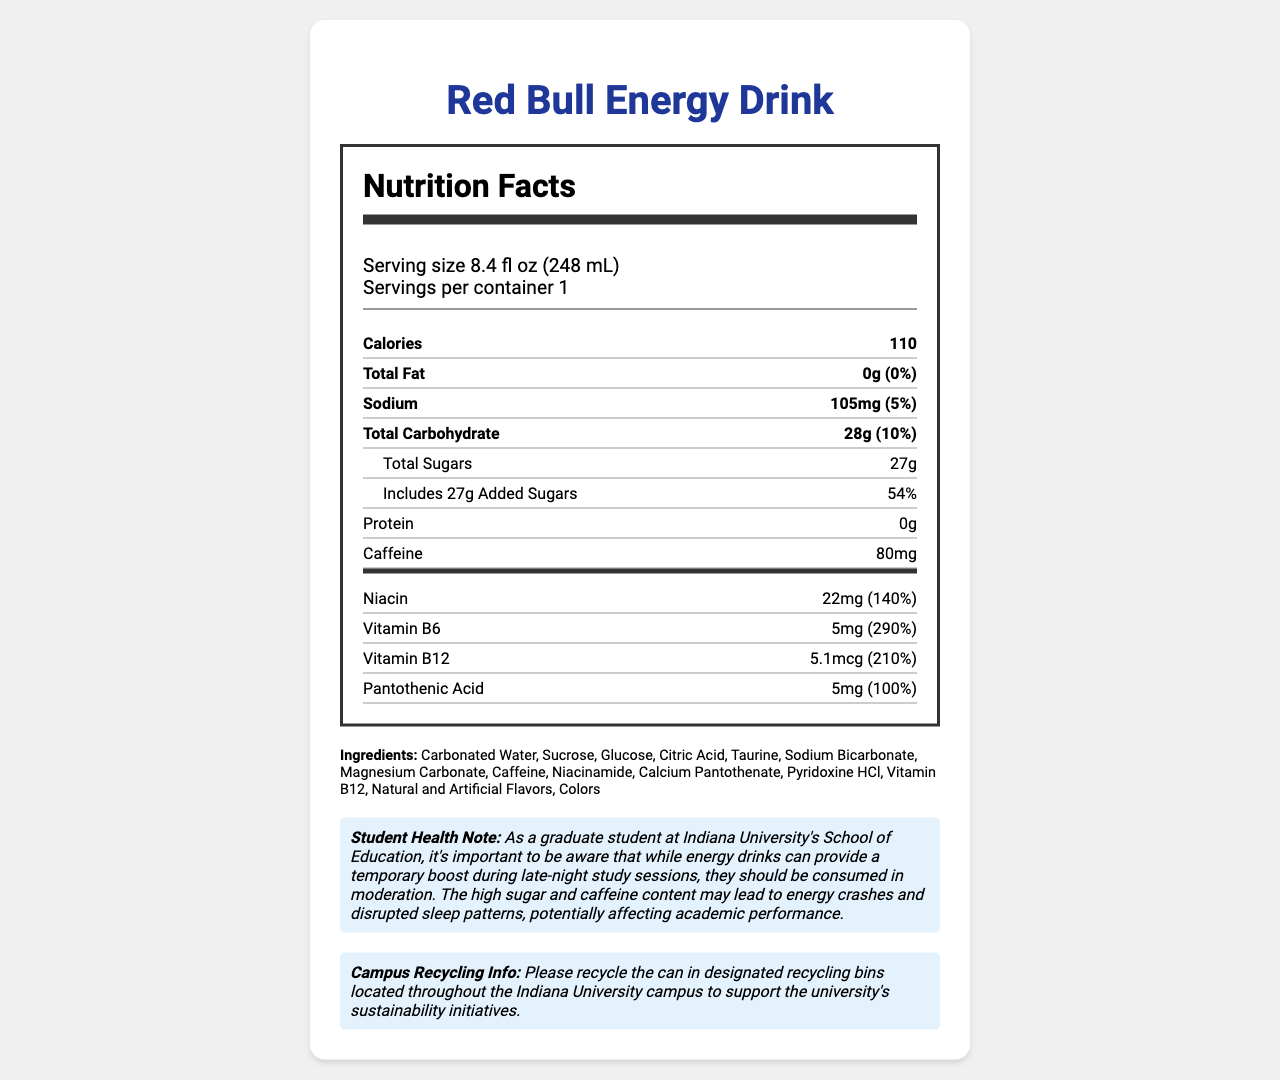what is the serving size of the Red Bull Energy Drink? The serving size is stated as "8.4 fl oz (248 mL)" at the beginning of the Nutrition Facts section.
Answer: 8.4 fl oz (248 mL) how many calories are in one serving of this energy drink? The number of calories per serving is listed as "110" under the Calories section.
Answer: 110 how much sodium does one serving of Red Bull contain? The sodium content per serving is listed as "105mg" under the Sodium section.
Answer: 105mg what is the percentage of the daily value for niacin in one serving? The daily value percentage for niacin is listed as "140%" under the vitamins and minerals section.
Answer: 140% how much caffeine is in one serving of this energy drink? The caffeine content is listed as "80mg" under the Caffeine section.
Answer: 80mg which vitamin has the highest percentage of the daily value? A. Niacin B. Vitamin B6 C. Vitamin B12 D. Pantothenic Acid Vitamin B6 has the highest daily value percentage at 290%, as listed under the vitamins and minerals section.
Answer: B. Vitamin B6 how many grams of added sugars are in one serving? A. 10g B. 20g C. 27g D. 30g The amount of added sugars is listed as "27g" under the Total Sugars section.
Answer: C. 27g which of the following is not listed as an ingredient in this energy drink? A. Carbonated Water B. Aspartame C. Sucrose D. Taurine Aspartame is not listed; the ingredient list includes Carbonated Water, Sucrose, Glucose, Citric Acid, Taurine, etc.
Answer: B. Aspartame does the product contain any major allergens? The allergen information section states, "This product does not contain any major allergens."
Answer: No describe the main idea of the document. The document is a comprehensive summary of the nutritional contents of Red Bull Energy Drink, intended to inform consumers about its health implications and proper disposal.
Answer: The document provides detailed nutrition information for Red Bull Energy Drink, including serving size, calories, fat, sodium, carbohydrates, sugars, protein, caffeine, and vitamins. It lists the ingredients, mentions the absence of major allergens, offers a health note for students, and includes information about campus recycling. how many vitamins and minerals are listed on the nutrition label? The nutrition label lists four vitamins and minerals: Niacin, Vitamin B6, Vitamin B12, and Pantothenic Acid.
Answer: Four what percentage of the daily value does the total carbohydrate in one serving represent? The daily value percentage for total carbohydrates is listed as "10%" under the Total Carbohydrate section.
Answer: 10% based on the student health note, should energy drinks be consumed regularly during late-night study sessions? The student health note advises moderation due to the high sugar and caffeine content that may lead to energy crashes and disrupted sleep patterns.
Answer: No does the document mention the recycling program at Indiana University? The recycling information section mentions designated recycling bins throughout the Indiana University campus.
Answer: Yes can you determine the exact amount of glucose in the product? The document lists glucose as an ingredient but does not specify the exact amount.
Answer: Cannot be determined 